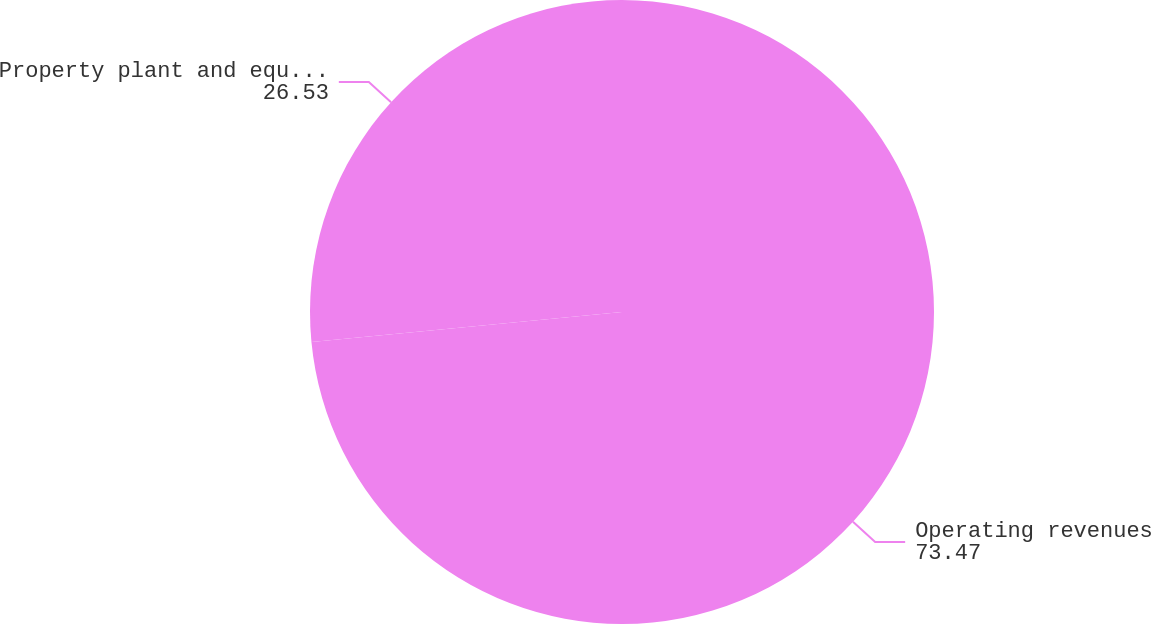Convert chart. <chart><loc_0><loc_0><loc_500><loc_500><pie_chart><fcel>Operating revenues<fcel>Property plant and equipment<nl><fcel>73.47%<fcel>26.53%<nl></chart> 